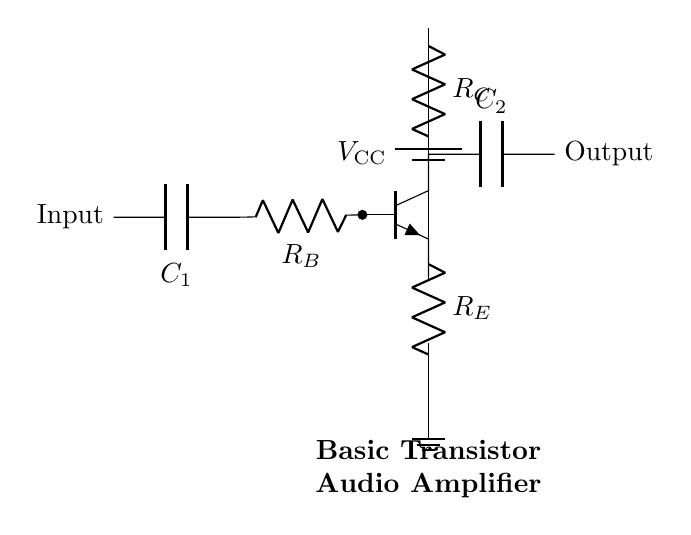What is the purpose of R_C in this circuit? R_C, or the collector resistor, is used to limit the current flowing through the collector of the transistor, ensuring appropriate biasing and stability of the transistor's function in amplification.
Answer: Limit current What type of transistor is shown in the circuit? The circuit diagram depicts an npn transistor, identifiable by its configuration and notation, which indicates it has a negative type of semiconductor (n) for both the emitter and collector, with a positive base.
Answer: NPN What component is located between the input and the base of the transistor? The component between the input and the base is a resistor, R_B, which is used to control the base current into the transistor, allowing for proper operation and gain in the amplifier circuit.
Answer: R_B How many capacitors are present in this circuit? There are two capacitors in the circuit: C_1, which is connected to the base, and C_2, which is connected to the output, both serving different functions in filtering and coupling signals.
Answer: Two What connection does the emitter of the transistor have? The emitter of the transistor is connected to a resistor, R_E, which is in turn connected to ground. This configuration helps stabilize the operating point of the transistor and control its gain.
Answer: To ground What does C_2 do in this amplifier circuit? C_2, the capacitor connected to the output, acts as a coupling capacitor that blocks DC components while allowing AC signals to pass through, which is essential in audio applications where only the AC signal (audio) is desired at the output.
Answer: Coupling 